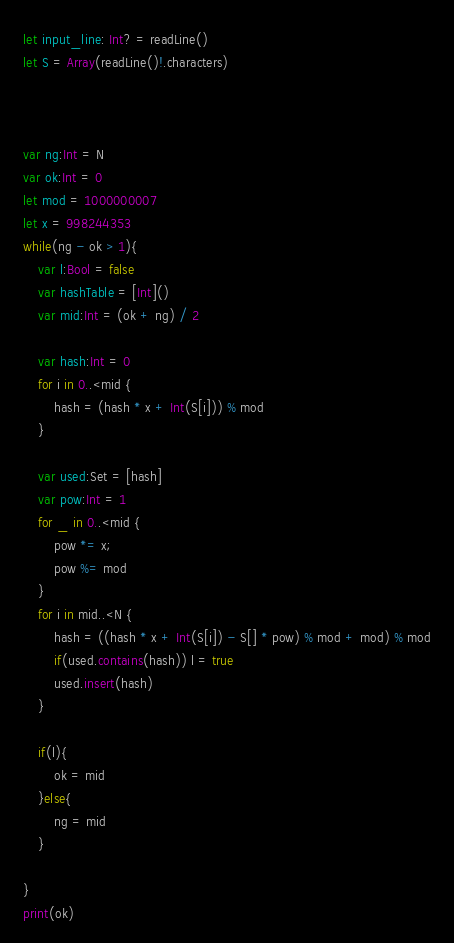Convert code to text. <code><loc_0><loc_0><loc_500><loc_500><_Swift_>let input_line: Int? = readLine()
let S = Array(readLine()!.characters)



var ng:Int = N
var ok:Int = 0
let mod = 1000000007
let x = 998244353
while(ng - ok > 1){
    var l:Bool = false
    var hashTable = [Int]()
    var mid:Int = (ok + ng) / 2
    
    var hash:Int = 0
    for i in 0..<mid {
        hash = (hash * x + Int(S[i])) % mod
    }
    
    var used:Set = [hash]
    var pow:Int = 1
    for _ in 0..<mid {
        pow *= x;
        pow %= mod
    }
    for i in mid..<N {
        hash = ((hash * x + Int(S[i]) - S[] * pow) % mod + mod) % mod
        if(used.contains(hash)) l = true
        used.insert(hash)
    }
    
    if(l){
        ok = mid
    }else{
        ng = mid
    }
    
}
print(ok)
</code> 